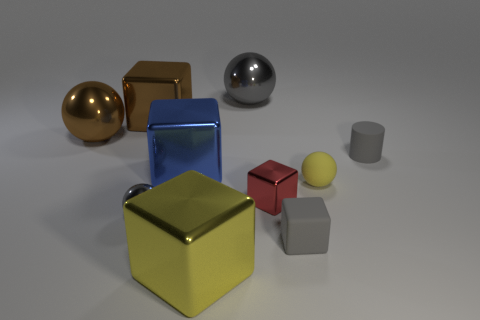What material is the brown object that is the same shape as the big gray shiny thing?
Give a very brief answer. Metal. The block that is the same color as the tiny rubber cylinder is what size?
Your answer should be compact. Small. Is there a ball that has the same color as the small rubber cube?
Provide a succinct answer. Yes. Is the color of the tiny rubber cylinder the same as the ball that is in front of the matte ball?
Make the answer very short. Yes. There is a big ball behind the brown ball; what is its material?
Provide a short and direct response. Metal. What is the size of the yellow rubber thing that is the same shape as the large gray object?
Keep it short and to the point. Small. Is the number of tiny gray cylinders that are to the left of the matte cube less than the number of gray rubber balls?
Provide a succinct answer. No. Is there a big purple metal cylinder?
Your answer should be very brief. No. There is another rubber thing that is the same shape as the blue object; what color is it?
Your response must be concise. Gray. There is a rubber object that is in front of the tiny red metallic object; does it have the same color as the small rubber cylinder?
Offer a very short reply. Yes. 